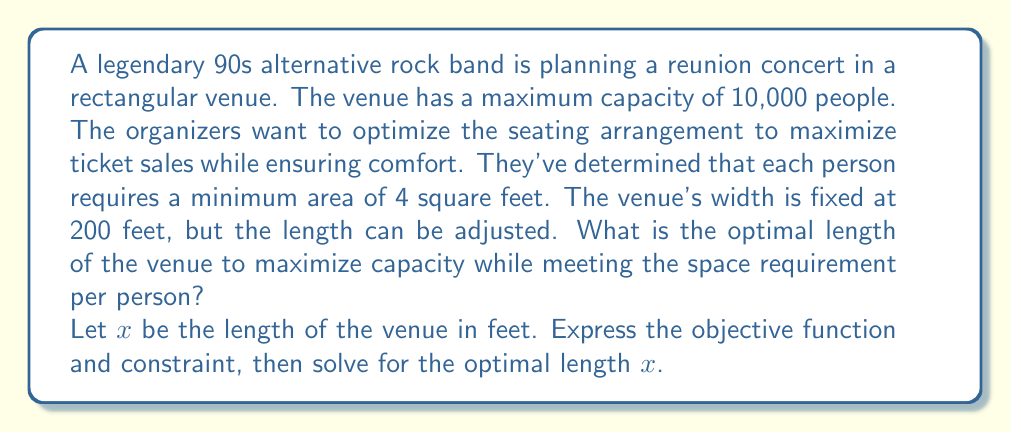Could you help me with this problem? To solve this optimization problem, we'll follow these steps:

1) First, let's define our variables:
   $x$ = length of the venue (in feet)
   $w$ = width of the venue (given as 200 feet)

2) The objective is to maximize the number of people. This can be expressed as the total area divided by the area per person:

   Objective function: $f(x) = \frac{wx}{4}$ = $\frac{200x}{4}$ = $50x$

3) The constraint is that the total number of people cannot exceed 10,000:

   Constraint: $50x \leq 10,000$

4) To find the optimal solution, we need to maximize $f(x)$ subject to this constraint. Since $f(x)$ is a linear function, its maximum value will occur at the boundary of the constraint.

5) Solving the constraint equation:
   
   $50x = 10,000$
   $x = 200$

6) Therefore, the optimal length of the venue is 200 feet.

7) We can verify that this satisfies the space requirement:
   
   Total area = $200 \text{ ft} \times 200 \text{ ft} = 40,000 \text{ sq ft}$
   Area per person = $40,000 \text{ sq ft} / 10,000 \text{ people} = 4 \text{ sq ft/person}$

This solution maximizes the capacity while meeting the space requirement per person.
Answer: The optimal length of the venue is 200 feet. 